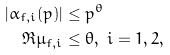<formula> <loc_0><loc_0><loc_500><loc_500>| \alpha _ { f , i } ( p ) | & \leq p ^ { \theta } \\ \Re \mu _ { f , i } & \leq \theta , \ i = 1 , 2 ,</formula> 